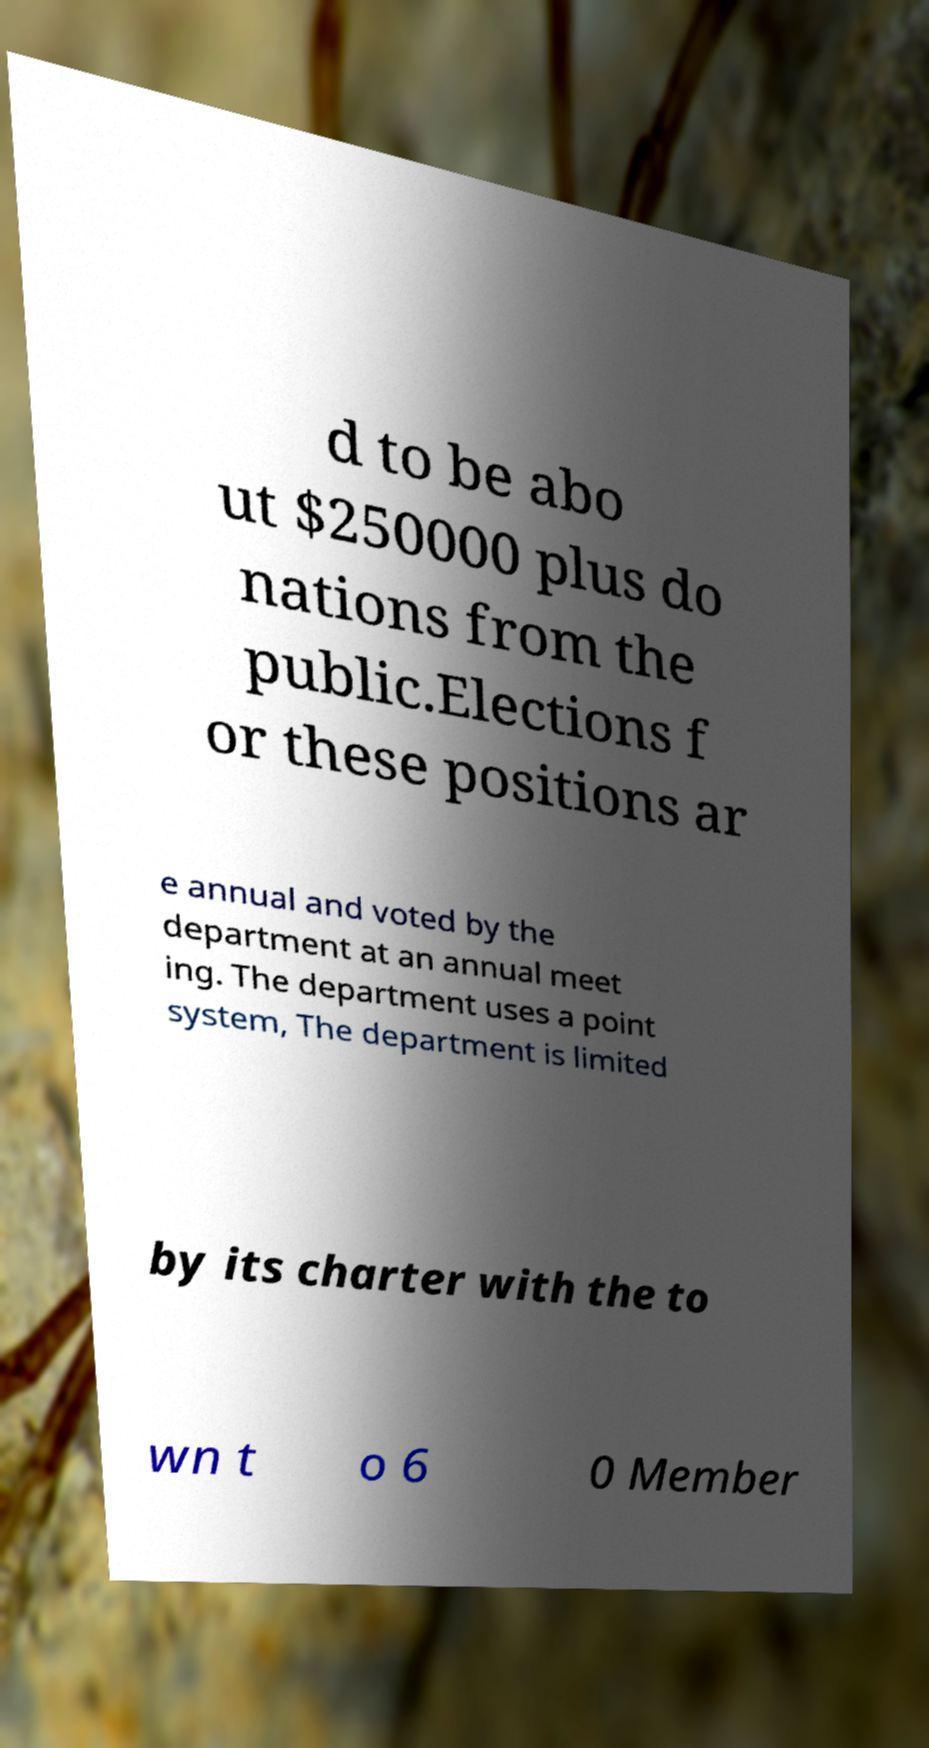Can you read and provide the text displayed in the image?This photo seems to have some interesting text. Can you extract and type it out for me? d to be abo ut $250000 plus do nations from the public.Elections f or these positions ar e annual and voted by the department at an annual meet ing. The department uses a point system, The department is limited by its charter with the to wn t o 6 0 Member 